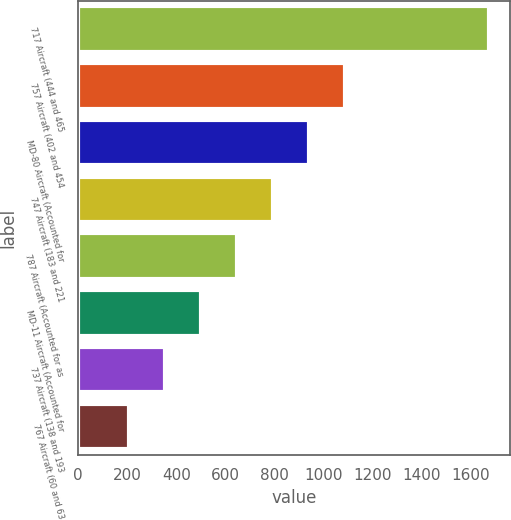<chart> <loc_0><loc_0><loc_500><loc_500><bar_chart><fcel>717 Aircraft (444 and 465<fcel>757 Aircraft (402 and 454<fcel>MD-80 Aircraft (Accounted for<fcel>747 Aircraft (183 and 221<fcel>787 Aircraft (Accounted for as<fcel>MD-11 Aircraft (Accounted for<fcel>737 Aircraft (138 and 193<fcel>767 Aircraft (60 and 63<nl><fcel>1674<fcel>1087.2<fcel>940.5<fcel>793.8<fcel>647.1<fcel>500.4<fcel>353.7<fcel>207<nl></chart> 